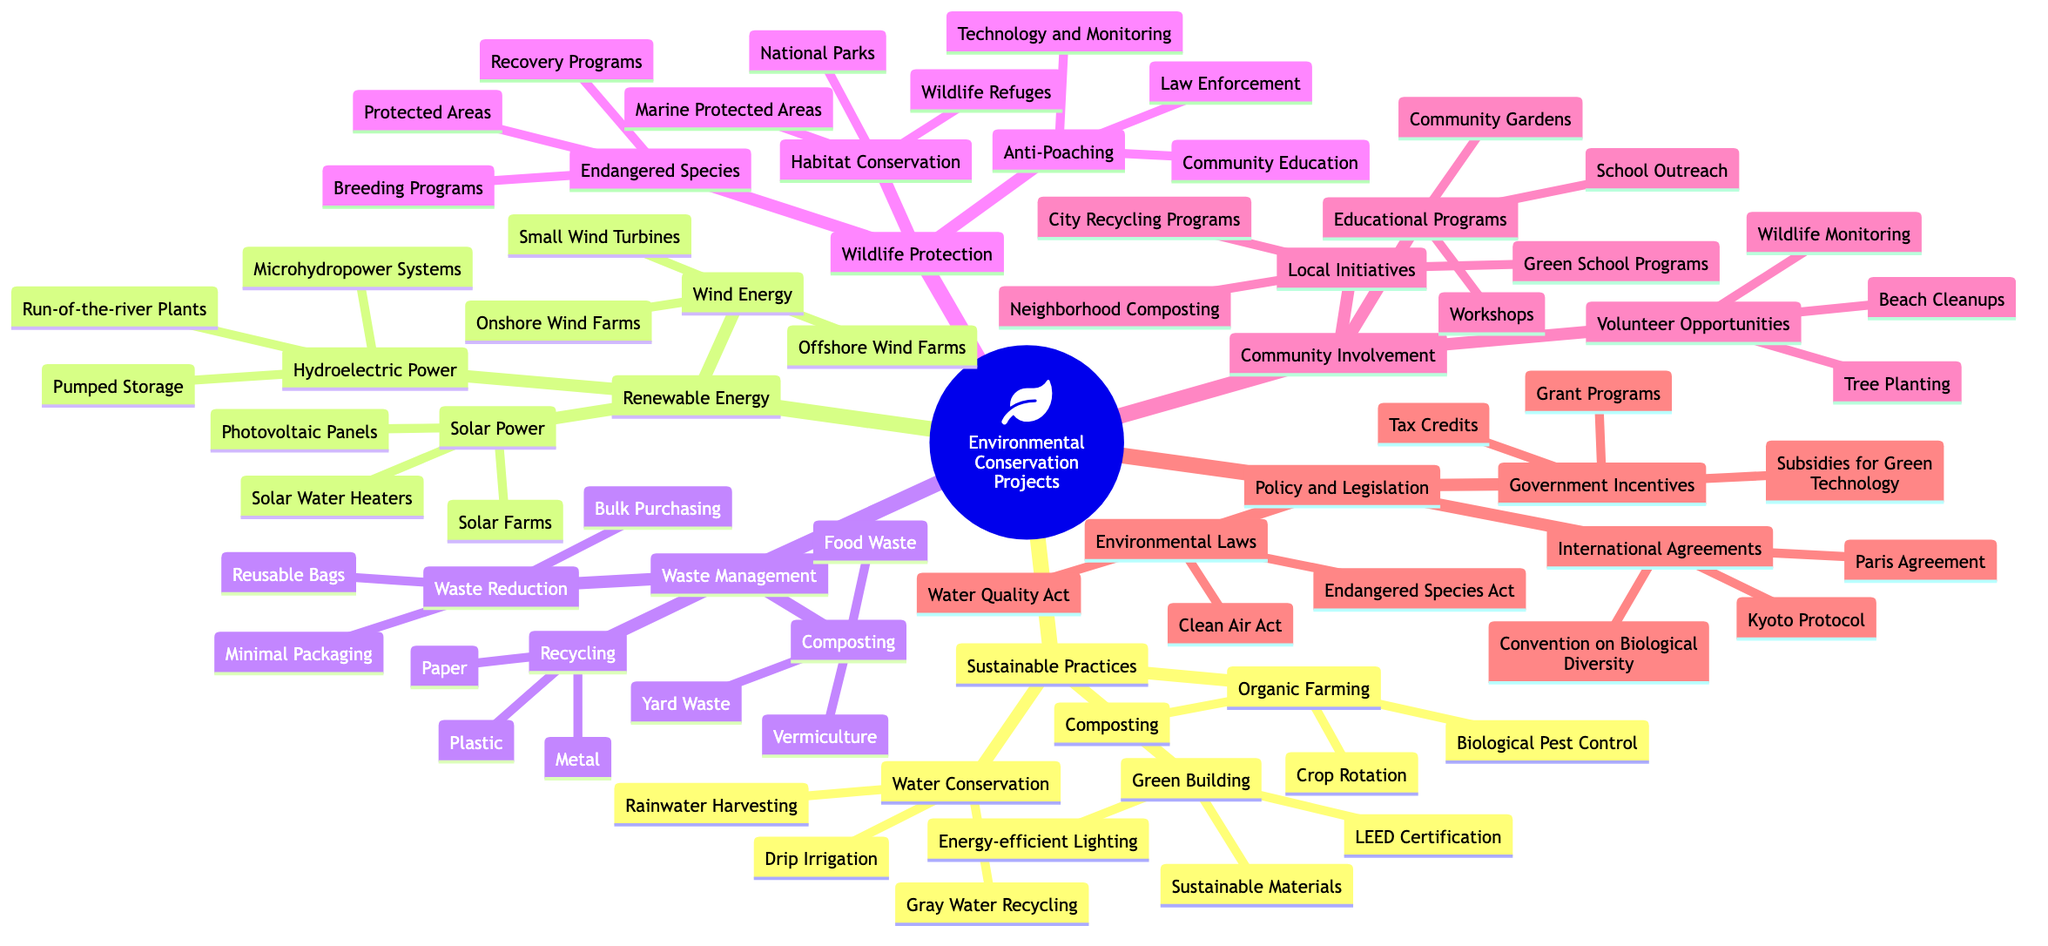What are examples of sustainable practices? The mind map shows three categories under sustainable practices: organic farming, water conservation, and green building. Each category contains specific methods, such as crop rotation and composting under organic farming.
Answer: Organic Farming, Water Conservation, Green Building How many renewable energy sources are listed in the diagram? The renewable energy section has three main nodes: solar power, wind energy, and hydroelectric power. Each of these represents a different type of renewable energy. Counting these nodes gives us three.
Answer: 3 Which method falls under wildlife protection? The wildlife protection category specifically lists three main components: habitat conservation, endangered species, and anti-poaching. From these, one example of a method is habitat conservation.
Answer: Habitat Conservation What community involvement opportunity is mentioned in the mind map? Under community involvement, several opportunities are listed such as educational programs, volunteer opportunities, and local initiatives. One example of a volunteer opportunity is beach cleanups.
Answer: Beach Cleanups Which international agreement is focused on climate change? The policy and legislation section contains several international agreements, including the Paris Agreement, which is specifically aimed at addressing climate change issues on a global scale.
Answer: Paris Agreement What type of renewable energy can use turbines? In the renewable energy section, both wind energy and hydroelectric power are listed. Wind energy specifically mentions onshore and offshore wind farms, which utilize turbines to generate electricity.
Answer: Wind Energy How many methods are suggested under waste reduction? The waste management section lists waste reduction methods, including reusable bags, bulk purchasing, and minimal packaging. This gives us a total of three methods under waste reduction.
Answer: 3 What act helps protect endangered species in the U.S.? In the policy and legislation section, the Endangered Species Act is specifically mentioned as a law designed to protect endangered species within the United States.
Answer: Endangered Species Act 